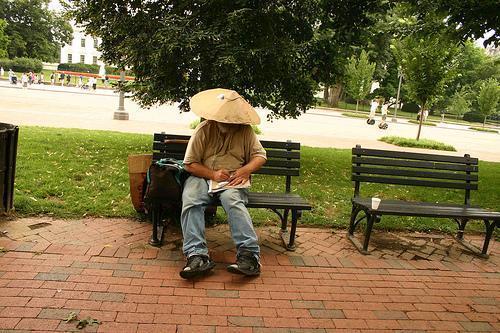How many people are the main focus of this photo?
Give a very brief answer. 1. How many benches are visible?
Give a very brief answer. 2. 